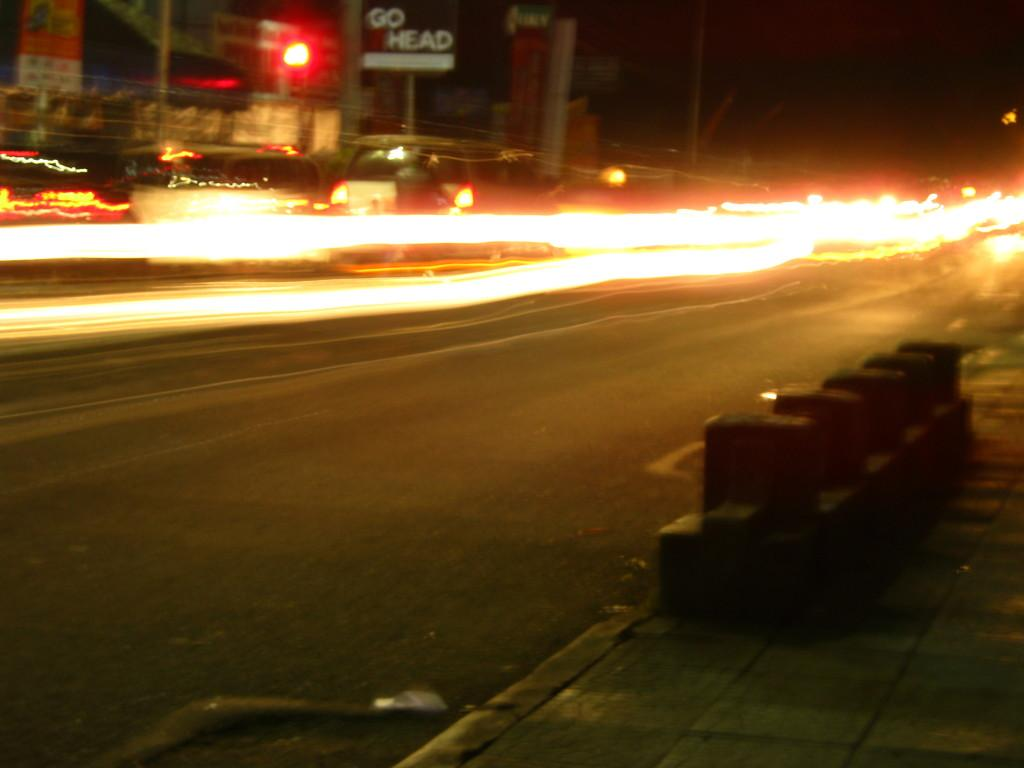What can be seen on the posters in the image? Unfortunately, the image is blurry, so it is difficult to discern the details on the posters. What type of vehicles are present in the image? There are cars in the image. Where are the posters and cars located in the image? The top side of the image contains posters and cars. Can you tell me how many cacti are visible in the image? There are no cacti present in the image; it features posters and cars. What color are the crayons used to draw the veins in the image? There are no crayons or veins depicted in the image. 